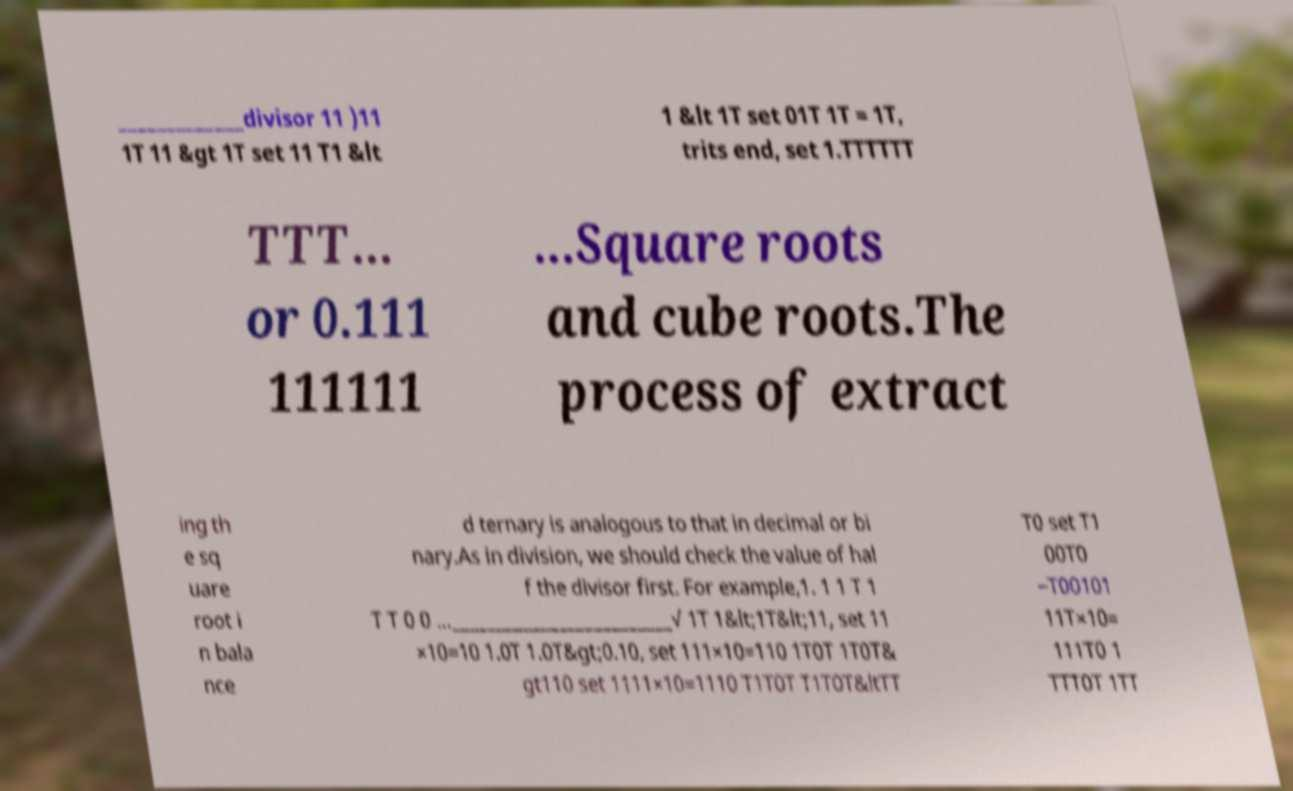Can you read and provide the text displayed in the image?This photo seems to have some interesting text. Can you extract and type it out for me? _____________divisor 11 )11 1T 11 &gt 1T set 11 T1 &lt 1 &lt 1T set 01T 1T = 1T, trits end, set 1.TTTTTT TTT... or 0.111 111111 ...Square roots and cube roots.The process of extract ing th e sq uare root i n bala nce d ternary is analogous to that in decimal or bi nary.As in division, we should check the value of hal f the divisor first. For example,1. 1 1 T 1 T T 0 0 ..._________________________√ 1T 1&lt;1T&lt;11, set 11 ×10=10 1.0T 1.0T&gt;0.10, set 111×10=110 1T0T 1T0T& gt110 set 1111×10=1110 T1T0T T1T0T&ltTT T0 set T1 00T0 −T00101 11T×10= 111T0 1 TTT0T 1TT 